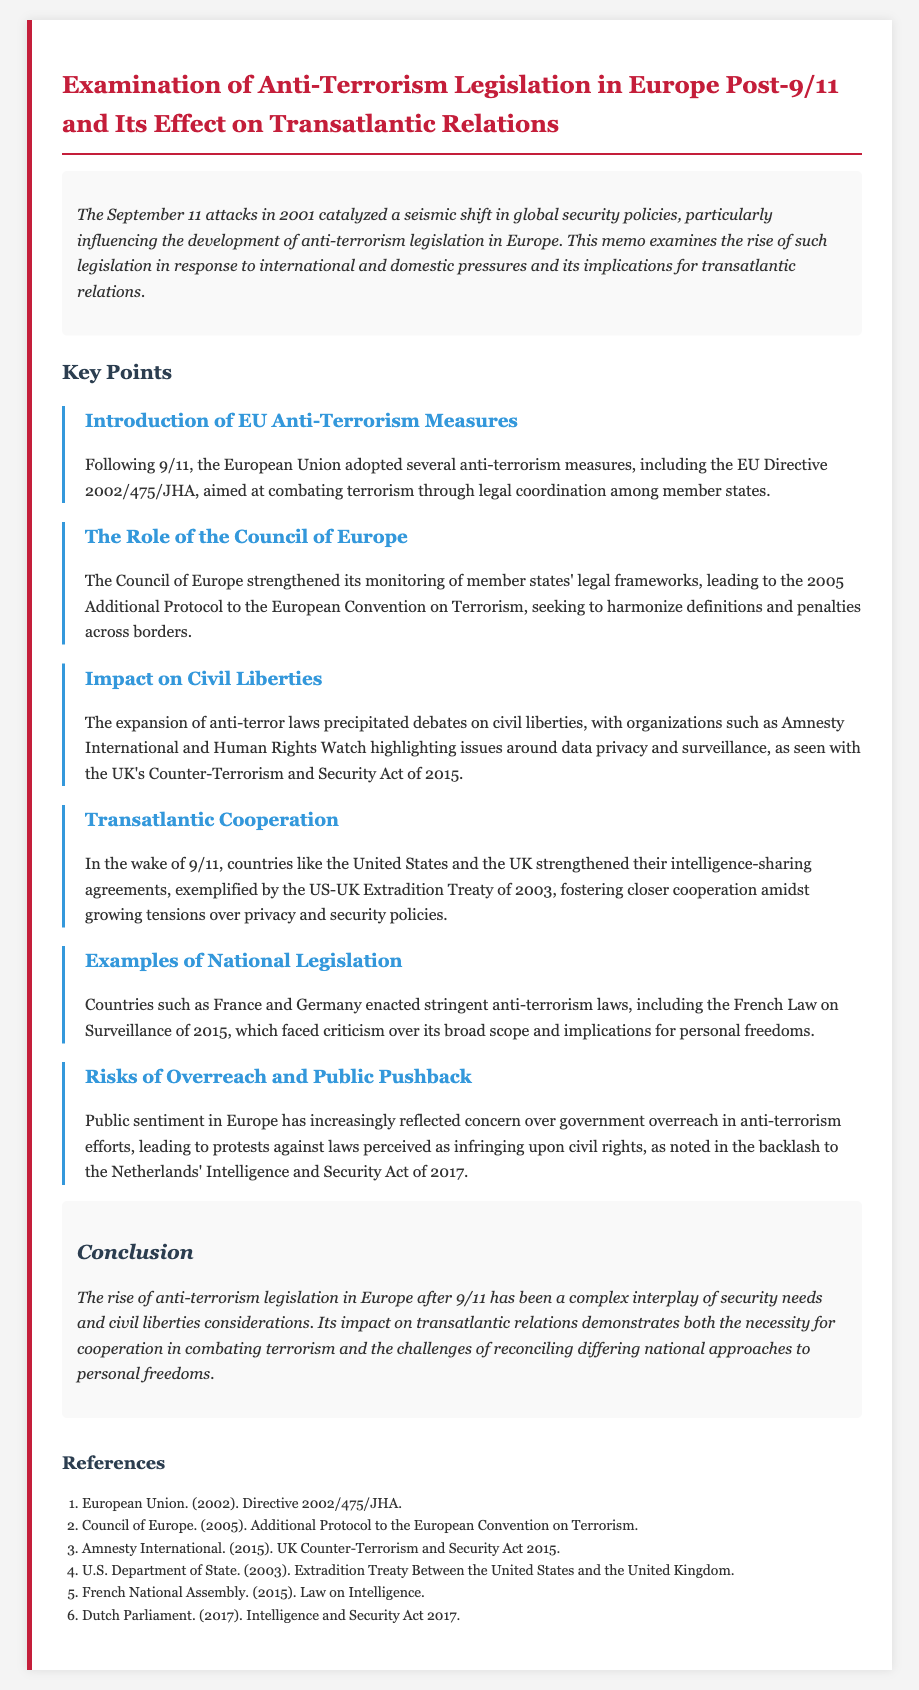What is the title of the memo? The title of the memo is the main heading at the top of the document.
Answer: Examination of Anti-Terrorism Legislation in Europe Post-9/11 and Its Effect on Transatlantic Relations What year did the September 11 attacks occur? The year of the September 11 attacks is mentioned in the introduction as a pivotal event.
Answer: 2001 What EU directive was adopted in response to 9/11? This directive is specifically mentioned under the introduction of EU anti-terrorism measures.
Answer: EU Directive 2002/475/JHA What does the Council of Europe aim to harmonize? This goal is stated in the section discussing the role of the Council of Europe.
Answer: Definitions and penalties Which organization highlighted issues around data privacy and surveillance? This organization is referenced in relation to civil liberties concerns.
Answer: Amnesty International What was the year of the UK's Counter-Terrorism and Security Act? This year is mentioned in the discussion on civil liberties and is a key legislative reference.
Answer: 2015 What type of public sentiment is noted in relation to anti-terrorism laws in Europe? The public sentiment is mentioned in the context of concerns regarding government overreach.
Answer: Concern What was the reaction in the Netherlands to its Intelligence and Security Act? The reaction is described as a notable public response to this law.
Answer: Backlash What complex interplay is mentioned in the conclusion of the memo? This interplay refers to different factors discussed in the conclusion section of the memo.
Answer: Security needs and civil liberties considerations 